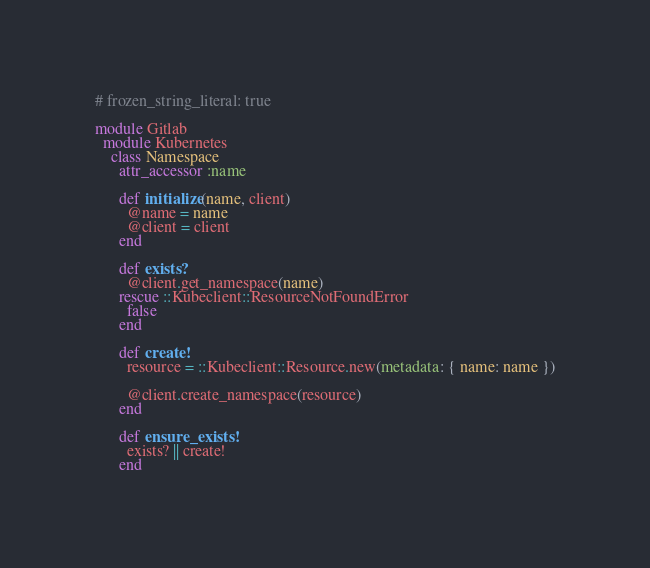<code> <loc_0><loc_0><loc_500><loc_500><_Ruby_># frozen_string_literal: true

module Gitlab
  module Kubernetes
    class Namespace
      attr_accessor :name

      def initialize(name, client)
        @name = name
        @client = client
      end

      def exists?
        @client.get_namespace(name)
      rescue ::Kubeclient::ResourceNotFoundError
        false
      end

      def create!
        resource = ::Kubeclient::Resource.new(metadata: { name: name })

        @client.create_namespace(resource)
      end

      def ensure_exists!
        exists? || create!
      end</code> 